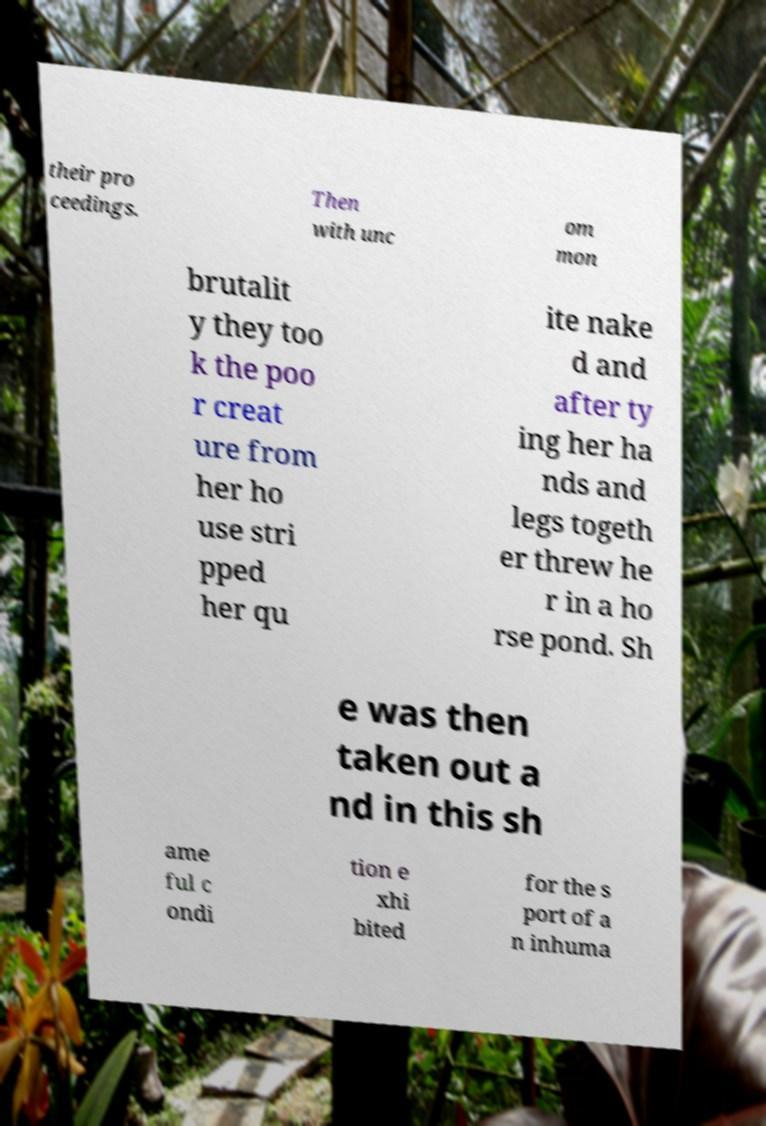Please identify and transcribe the text found in this image. their pro ceedings. Then with unc om mon brutalit y they too k the poo r creat ure from her ho use stri pped her qu ite nake d and after ty ing her ha nds and legs togeth er threw he r in a ho rse pond. Sh e was then taken out a nd in this sh ame ful c ondi tion e xhi bited for the s port of a n inhuma 